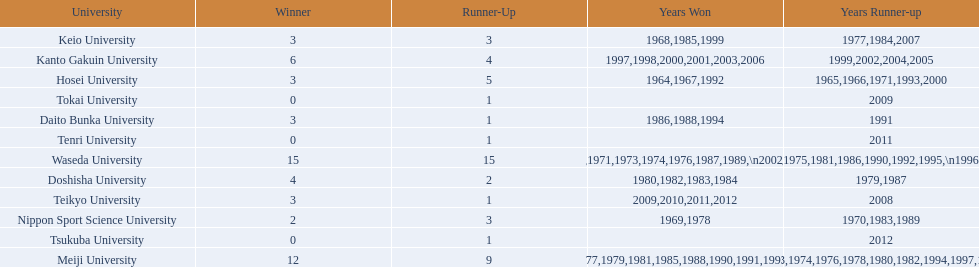What university were there in the all-japan university rugby championship? Waseda University, Meiji University, Kanto Gakuin University, Doshisha University, Hosei University, Keio University, Daito Bunka University, Nippon Sport Science University, Teikyo University, Tokai University, Tenri University, Tsukuba University. I'm looking to parse the entire table for insights. Could you assist me with that? {'header': ['University', 'Winner', 'Runner-Up', 'Years Won', 'Years Runner-up'], 'rows': [['Keio University', '3', '3', '1968,1985,1999', '1977,1984,2007'], ['Kanto Gakuin University', '6', '4', '1997,1998,2000,2001,2003,2006', '1999,2002,2004,2005'], ['Hosei University', '3', '5', '1964,1967,1992', '1965,1966,1971,1993,2000'], ['Tokai University', '0', '1', '', '2009'], ['Daito Bunka University', '3', '1', '1986,1988,1994', '1991'], ['Tenri University', '0', '1', '', '2011'], ['Waseda University', '15', '15', '1965,1966,1968,1970,1971,1973,1974,1976,1987,1989,\\n2002,2004,2005,2007,2008', '1964,1967,1969,1972,1975,1981,1986,1990,1992,1995,\\n1996,2001,2003,2006,2010'], ['Doshisha University', '4', '2', '1980,1982,1983,1984', '1979,1987'], ['Teikyo University', '3', '1', '2009,2010,2011,2012', '2008'], ['Nippon Sport Science University', '2', '3', '1969,1978', '1970,1983,1989'], ['Tsukuba University', '0', '1', '', '2012'], ['Meiji University', '12', '9', '1972,1975,1977,1979,1981,1985,1988,1990,1991,1993,\\n1995,1996', '1973,1974,1976,1978,1980,1982,1994,1997,1998']]} Of these who had more than 12 wins? Waseda University. 